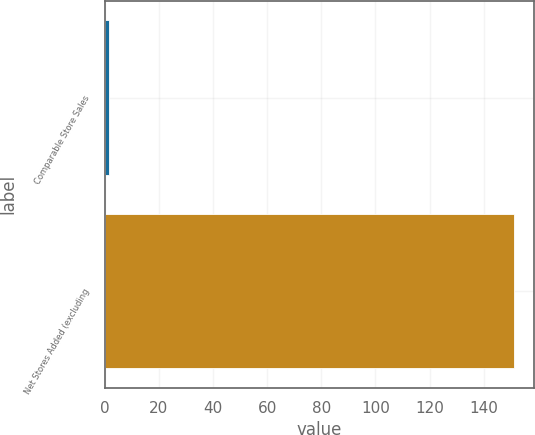Convert chart to OTSL. <chart><loc_0><loc_0><loc_500><loc_500><bar_chart><fcel>Comparable Store Sales<fcel>Net Stores Added (excluding<nl><fcel>1.5<fcel>151<nl></chart> 